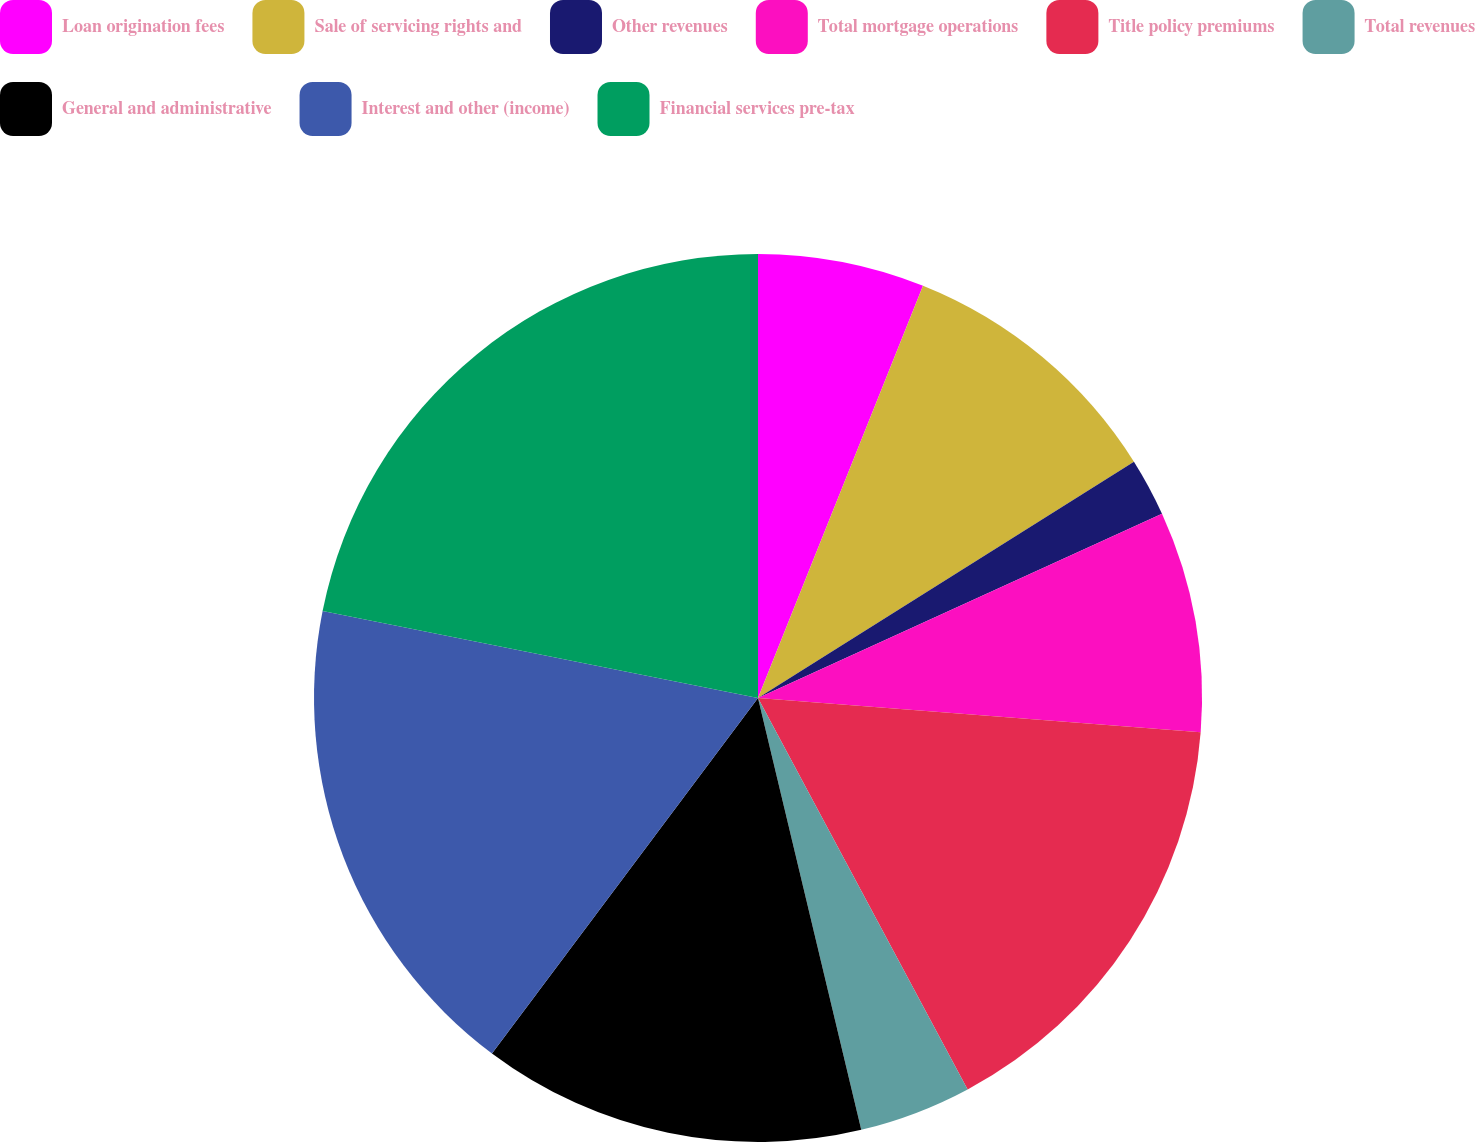Convert chart to OTSL. <chart><loc_0><loc_0><loc_500><loc_500><pie_chart><fcel>Loan origination fees<fcel>Sale of servicing rights and<fcel>Other revenues<fcel>Total mortgage operations<fcel>Title policy premiums<fcel>Total revenues<fcel>General and administrative<fcel>Interest and other (income)<fcel>Financial services pre-tax<nl><fcel>6.06%<fcel>10.01%<fcel>2.12%<fcel>8.04%<fcel>15.94%<fcel>4.09%<fcel>13.96%<fcel>17.91%<fcel>21.86%<nl></chart> 